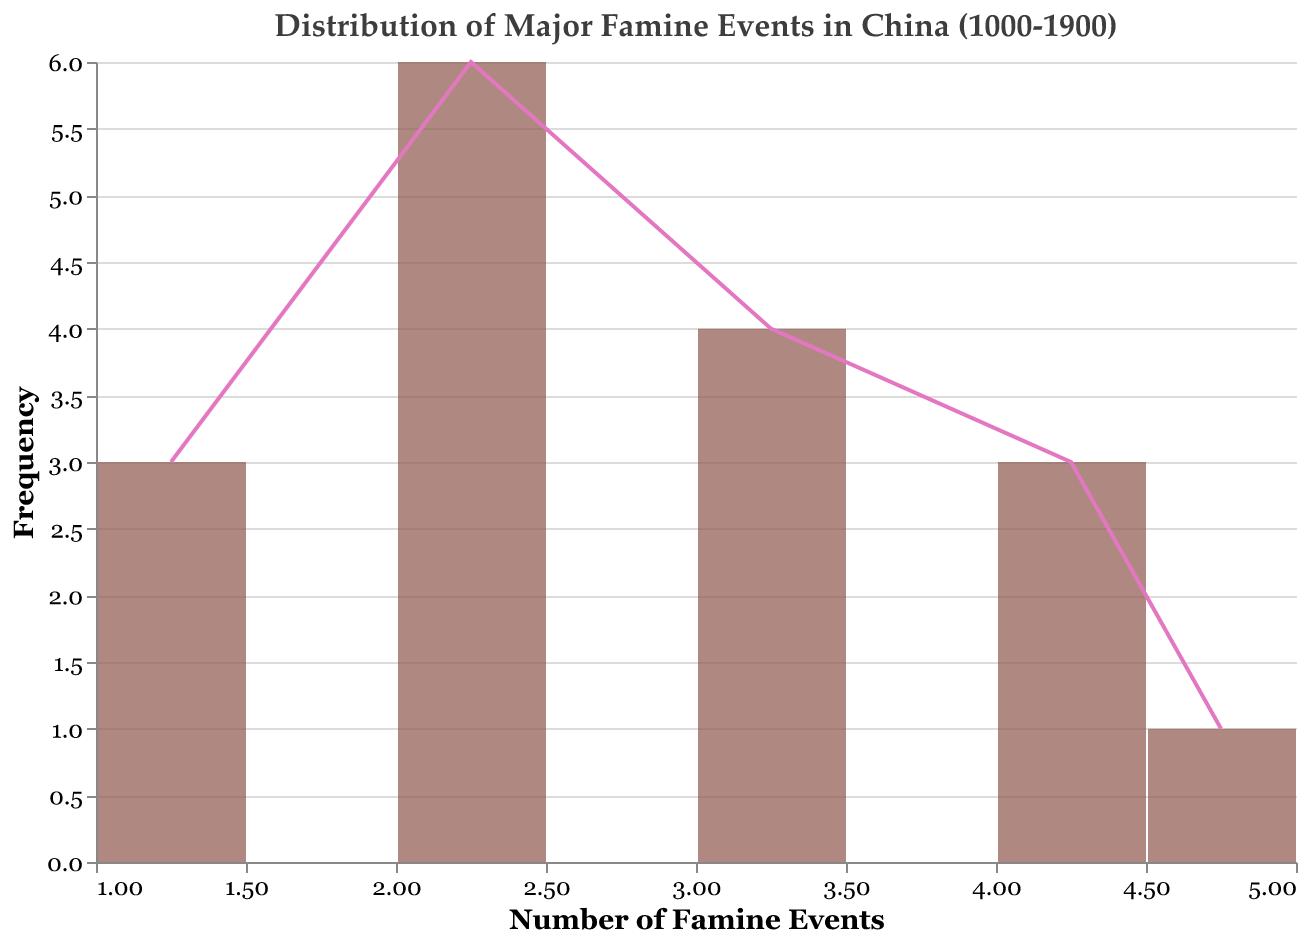What's the title of the distribution plot? The title of the distribution plot is located at the top and reads "Distribution of Major Famine Events in China (1000-1900)".
Answer: Distribution of Major Famine Events in China (1000-1900) Which color represents the bar in the plot? The bars in the plot are represented by a color that looks like dark red or brown.
Answer: Dark red or brown How many bins does the distribution plot have? Count the different intervals along the x-axis that group the number of famine events. Each interval represents a bin, and there are 5 bins visible in the plot.
Answer: 5 Which year had the highest number of famine events and what was that number? Find the highest bar or line point in the figure. The year associated with it is 1849, and the number of famine events in that year is 5.
Answer: 1849, 5 What is the most common number of famine events and its frequency? Identify the x-axis value with the highest bar or line point on the y-axis. The number of famine events is 2, and its frequency (height) is the highest, which is 6.
Answer: 2, 6 How many years had exactly 4 famine events? Look at the bin labeled "4" on the x-axis and check its height on the y-axis, which tells the count. The height indicates there were 3 years with 4 famine events.
Answer: 3 Is the occurrence of 1 famine event more frequent than 3 famine events? Compare the bar heights or line points for 1 and 3 famine events on the x-axis. The bar for 1 famine event is shorter, showing a frequency of 3, whereas for 3 famine events, it is higher with a frequency of 4.
Answer: No Calculate the average number of famine events per century. Sum all the famine events (2+1+3+2+1+4+3+2+1+2+3+4+2+3+2+5+4 = 44) and divide by the number of centuries (10).
Answer: 4.4 What is the median frequency of famine events in the distribution? List out the frequencies: 1, 1, 1, 2, 2, 2, 2, 2, 2, 3, 3, 3, 3, 4, 4, 4, 5. The middle value in this ordered list is 2.
Answer: 2 